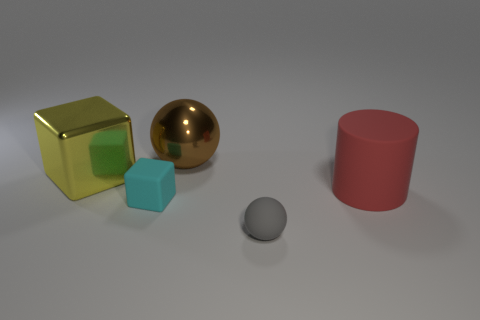Add 3 big green blocks. How many objects exist? 8 Subtract all cylinders. How many objects are left? 4 Subtract 0 yellow cylinders. How many objects are left? 5 Subtract all small brown matte objects. Subtract all large red matte objects. How many objects are left? 4 Add 3 small gray rubber balls. How many small gray rubber balls are left? 4 Add 3 small blue shiny blocks. How many small blue shiny blocks exist? 3 